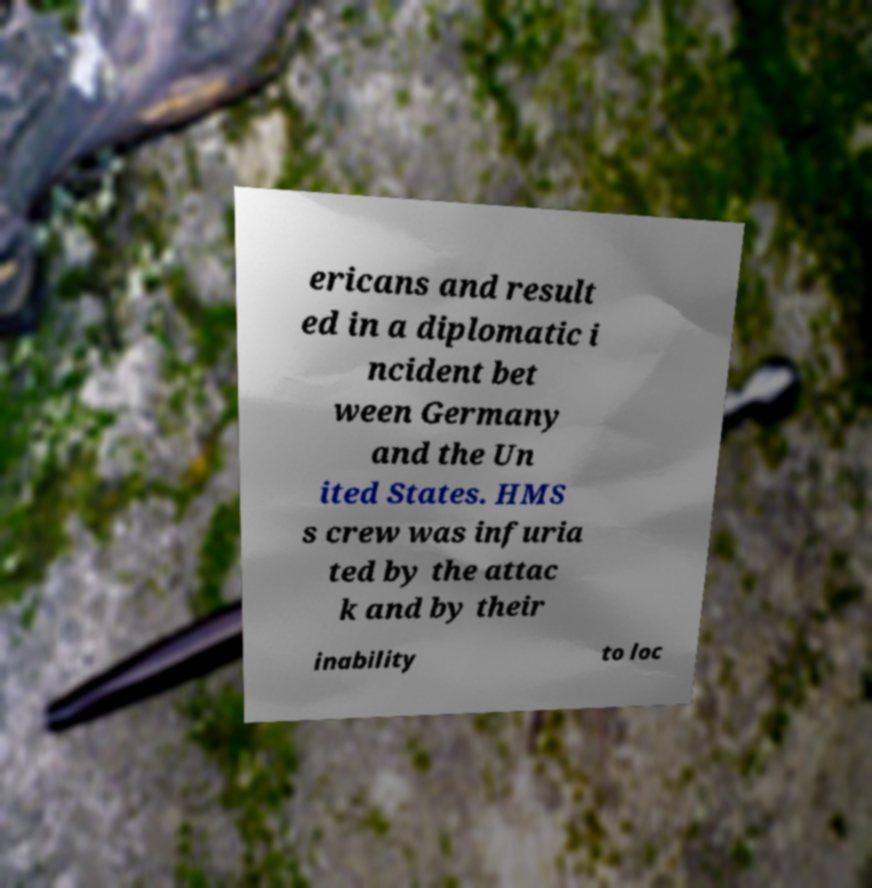Can you accurately transcribe the text from the provided image for me? ericans and result ed in a diplomatic i ncident bet ween Germany and the Un ited States. HMS s crew was infuria ted by the attac k and by their inability to loc 